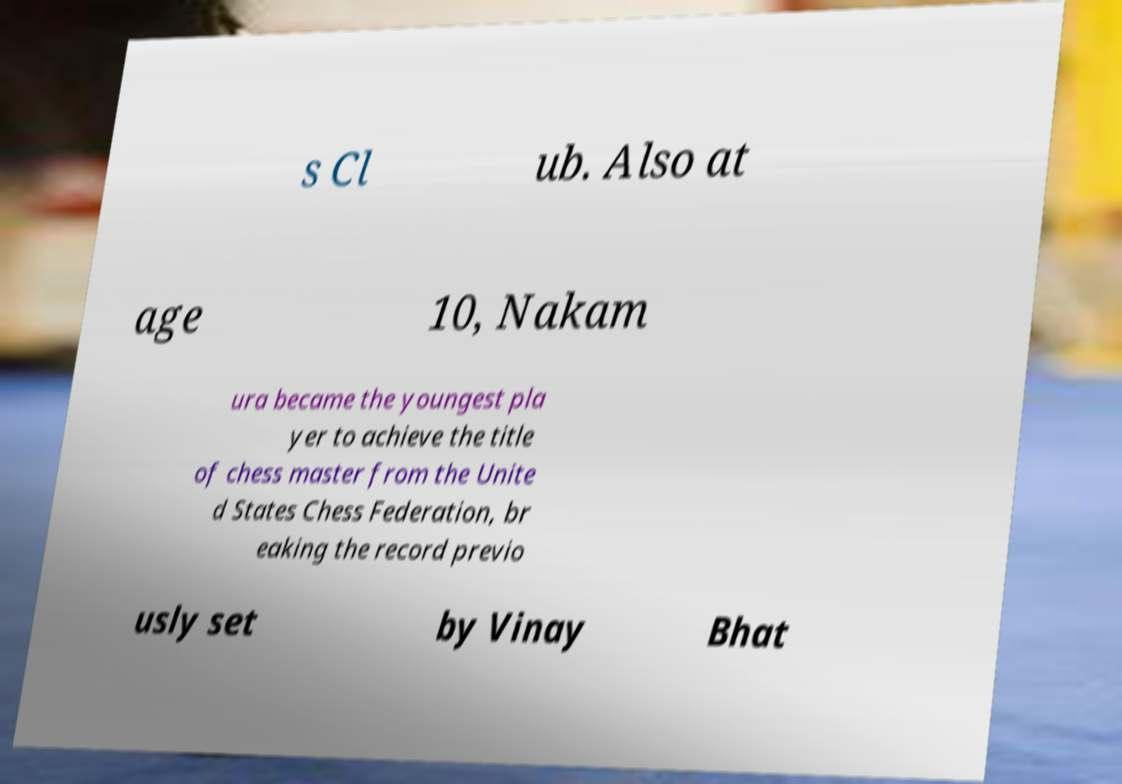Please read and relay the text visible in this image. What does it say? s Cl ub. Also at age 10, Nakam ura became the youngest pla yer to achieve the title of chess master from the Unite d States Chess Federation, br eaking the record previo usly set by Vinay Bhat 